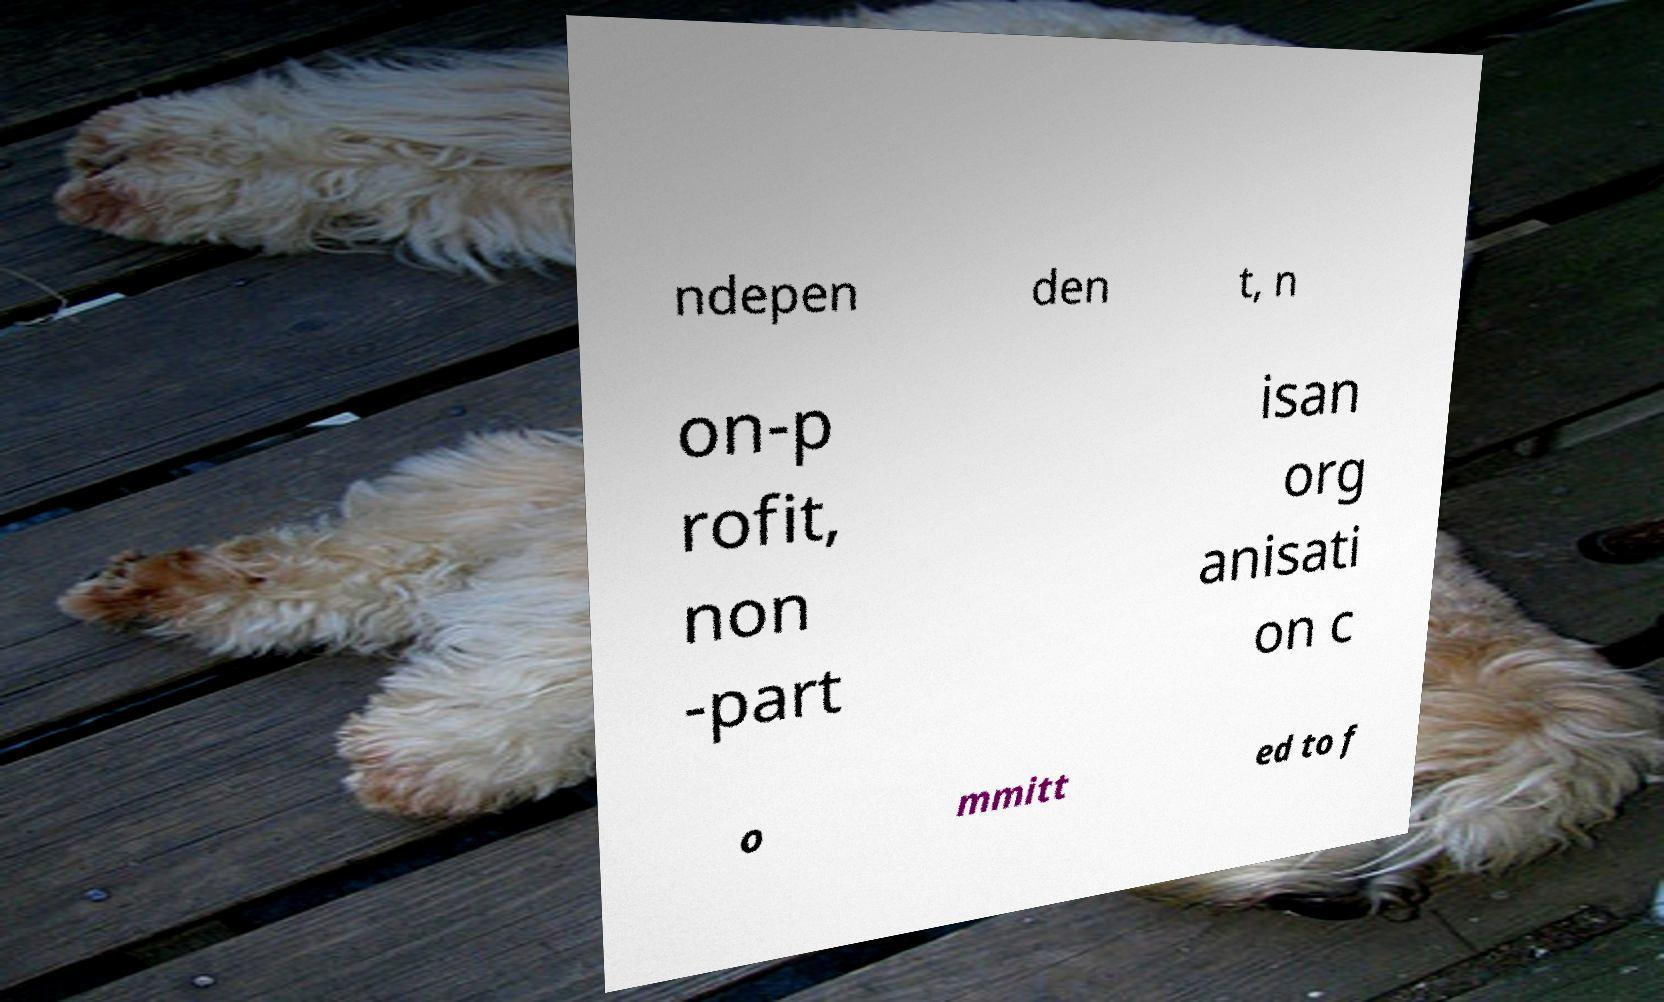There's text embedded in this image that I need extracted. Can you transcribe it verbatim? ndepen den t, n on-p rofit, non -part isan org anisati on c o mmitt ed to f 